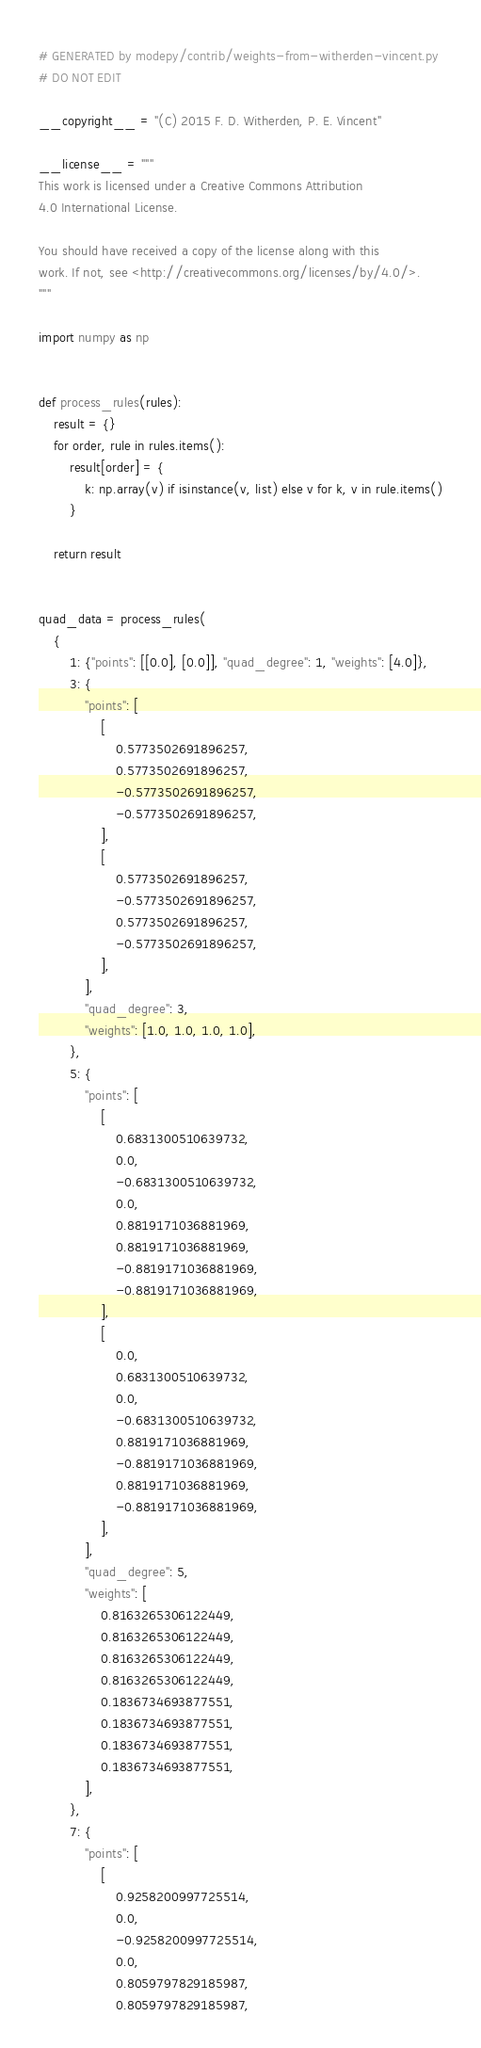<code> <loc_0><loc_0><loc_500><loc_500><_Python_># GENERATED by modepy/contrib/weights-from-witherden-vincent.py
# DO NOT EDIT

__copyright__ = "(C) 2015 F. D. Witherden, P. E. Vincent"

__license__ = """
This work is licensed under a Creative Commons Attribution
4.0 International License.

You should have received a copy of the license along with this
work. If not, see <http://creativecommons.org/licenses/by/4.0/>.
"""

import numpy as np


def process_rules(rules):
    result = {}
    for order, rule in rules.items():
        result[order] = {
            k: np.array(v) if isinstance(v, list) else v for k, v in rule.items()
        }

    return result


quad_data = process_rules(
    {
        1: {"points": [[0.0], [0.0]], "quad_degree": 1, "weights": [4.0]},
        3: {
            "points": [
                [
                    0.5773502691896257,
                    0.5773502691896257,
                    -0.5773502691896257,
                    -0.5773502691896257,
                ],
                [
                    0.5773502691896257,
                    -0.5773502691896257,
                    0.5773502691896257,
                    -0.5773502691896257,
                ],
            ],
            "quad_degree": 3,
            "weights": [1.0, 1.0, 1.0, 1.0],
        },
        5: {
            "points": [
                [
                    0.6831300510639732,
                    0.0,
                    -0.6831300510639732,
                    0.0,
                    0.8819171036881969,
                    0.8819171036881969,
                    -0.8819171036881969,
                    -0.8819171036881969,
                ],
                [
                    0.0,
                    0.6831300510639732,
                    0.0,
                    -0.6831300510639732,
                    0.8819171036881969,
                    -0.8819171036881969,
                    0.8819171036881969,
                    -0.8819171036881969,
                ],
            ],
            "quad_degree": 5,
            "weights": [
                0.8163265306122449,
                0.8163265306122449,
                0.8163265306122449,
                0.8163265306122449,
                0.1836734693877551,
                0.1836734693877551,
                0.1836734693877551,
                0.1836734693877551,
            ],
        },
        7: {
            "points": [
                [
                    0.9258200997725514,
                    0.0,
                    -0.9258200997725514,
                    0.0,
                    0.8059797829185987,
                    0.8059797829185987,</code> 